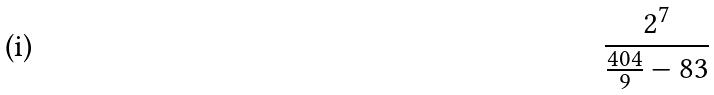Convert formula to latex. <formula><loc_0><loc_0><loc_500><loc_500>\frac { 2 ^ { 7 } } { \frac { 4 0 4 } { 9 } - 8 3 }</formula> 